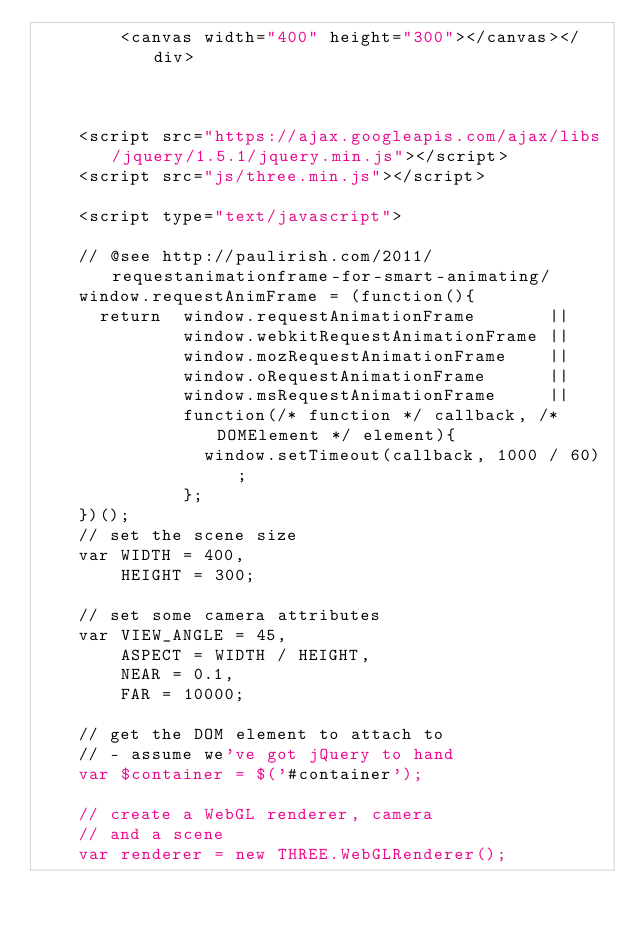<code> <loc_0><loc_0><loc_500><loc_500><_HTML_>		<canvas width="400" height="300"></canvas></div>
		
	
	
	<script src="https://ajax.googleapis.com/ajax/libs/jquery/1.5.1/jquery.min.js"></script>
	<script src="js/three.min.js"></script>
	
	<script type="text/javascript">
	
	// @see http://paulirish.com/2011/requestanimationframe-for-smart-animating/
	window.requestAnimFrame = (function(){
      return  window.requestAnimationFrame       || 
              window.webkitRequestAnimationFrame || 
              window.mozRequestAnimationFrame    || 
              window.oRequestAnimationFrame      || 
              window.msRequestAnimationFrame     || 
              function(/* function */ callback, /* DOMElement */ element){
                window.setTimeout(callback, 1000 / 60);
              };
    })();
	// set the scene size
	var WIDTH = 400,
	    HEIGHT = 300;
	
	// set some camera attributes
	var VIEW_ANGLE = 45,
	    ASPECT = WIDTH / HEIGHT,
	    NEAR = 0.1,
	    FAR = 10000;
	
	// get the DOM element to attach to
	// - assume we've got jQuery to hand
	var $container = $('#container');
	
	// create a WebGL renderer, camera
	// and a scene
	var renderer = new THREE.WebGLRenderer();</code> 